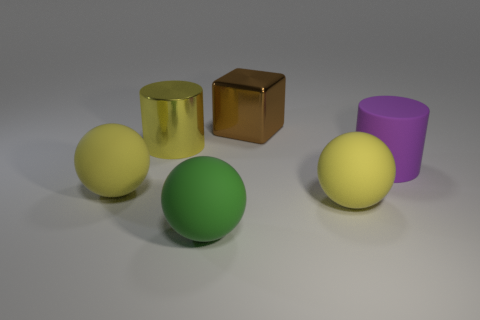Is there anything else that has the same shape as the big brown metallic object?
Make the answer very short. No. There is a large thing that is made of the same material as the yellow cylinder; what color is it?
Your answer should be very brief. Brown. Is the size of the shiny thing on the right side of the yellow cylinder the same as the green rubber sphere?
Provide a short and direct response. Yes. Are the purple cylinder and the ball to the left of the big green object made of the same material?
Your answer should be very brief. Yes. What color is the large metallic object right of the big green matte sphere?
Your answer should be very brief. Brown. Is there a yellow metal thing in front of the big yellow matte object that is to the left of the green object?
Provide a short and direct response. No. There is a ball on the right side of the brown metallic block; is it the same color as the cylinder on the left side of the big brown cube?
Make the answer very short. Yes. There is a purple rubber cylinder; what number of large rubber things are on the left side of it?
Offer a very short reply. 3. How many large matte spheres have the same color as the big shiny cylinder?
Your response must be concise. 2. Is the material of the yellow ball that is left of the big green rubber object the same as the big green object?
Ensure brevity in your answer.  Yes. 